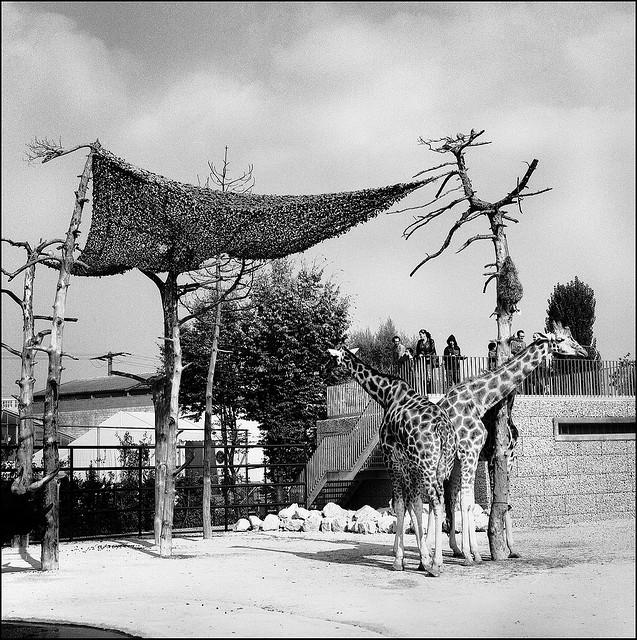Why are the people behind rails?

Choices:
A) see better
B) protect giraffes
C) protect them
D) keep clean protect them 